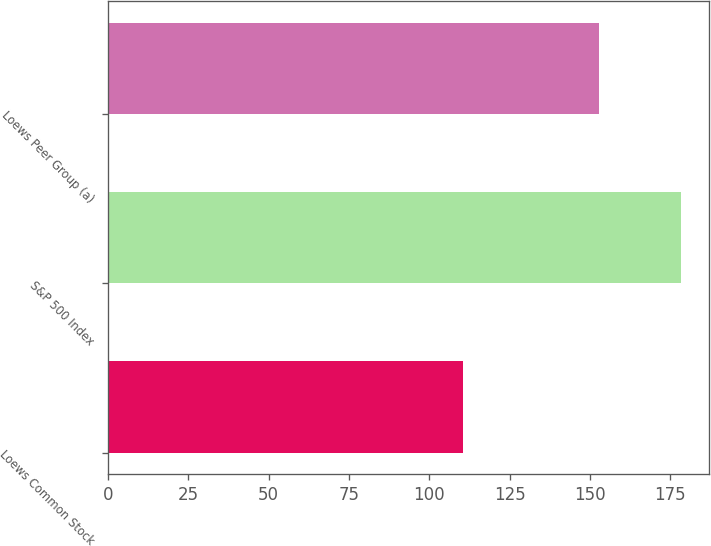Convert chart to OTSL. <chart><loc_0><loc_0><loc_500><loc_500><bar_chart><fcel>Loews Common Stock<fcel>S&P 500 Index<fcel>Loews Peer Group (a)<nl><fcel>110.59<fcel>178.29<fcel>152.84<nl></chart> 